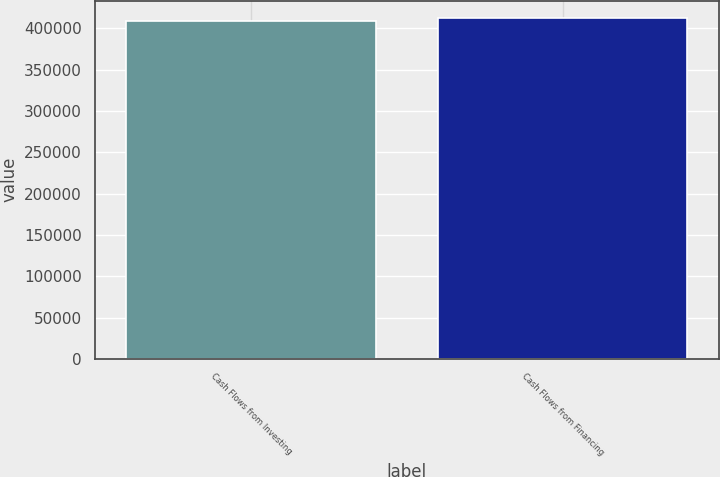Convert chart. <chart><loc_0><loc_0><loc_500><loc_500><bar_chart><fcel>Cash Flows from Investing<fcel>Cash Flows from Financing<nl><fcel>408997<fcel>412820<nl></chart> 